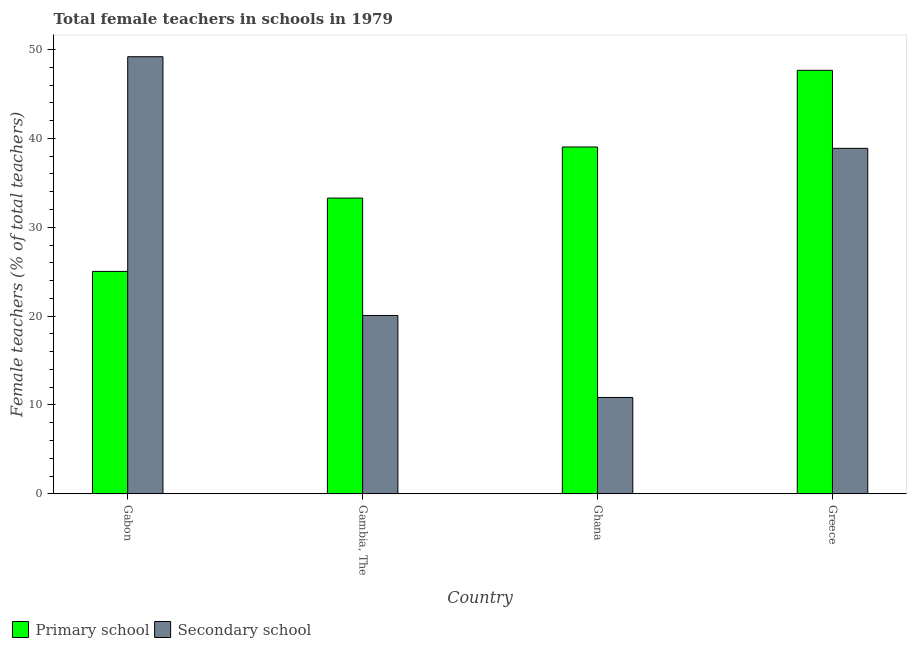How many different coloured bars are there?
Provide a succinct answer. 2. Are the number of bars per tick equal to the number of legend labels?
Offer a very short reply. Yes. Are the number of bars on each tick of the X-axis equal?
Your answer should be compact. Yes. How many bars are there on the 1st tick from the left?
Your answer should be compact. 2. What is the label of the 2nd group of bars from the left?
Your answer should be very brief. Gambia, The. What is the percentage of female teachers in primary schools in Gambia, The?
Keep it short and to the point. 33.28. Across all countries, what is the maximum percentage of female teachers in secondary schools?
Ensure brevity in your answer.  49.19. Across all countries, what is the minimum percentage of female teachers in primary schools?
Your answer should be compact. 25.03. In which country was the percentage of female teachers in secondary schools maximum?
Offer a terse response. Gabon. What is the total percentage of female teachers in secondary schools in the graph?
Your answer should be compact. 118.99. What is the difference between the percentage of female teachers in primary schools in Gabon and that in Ghana?
Your response must be concise. -14. What is the difference between the percentage of female teachers in primary schools in Gabon and the percentage of female teachers in secondary schools in Greece?
Your answer should be compact. -13.85. What is the average percentage of female teachers in secondary schools per country?
Give a very brief answer. 29.75. What is the difference between the percentage of female teachers in secondary schools and percentage of female teachers in primary schools in Ghana?
Ensure brevity in your answer.  -28.19. In how many countries, is the percentage of female teachers in primary schools greater than 36 %?
Offer a terse response. 2. What is the ratio of the percentage of female teachers in secondary schools in Gabon to that in Gambia, The?
Your answer should be very brief. 2.45. Is the percentage of female teachers in primary schools in Gabon less than that in Gambia, The?
Make the answer very short. Yes. Is the difference between the percentage of female teachers in secondary schools in Gabon and Ghana greater than the difference between the percentage of female teachers in primary schools in Gabon and Ghana?
Give a very brief answer. Yes. What is the difference between the highest and the second highest percentage of female teachers in secondary schools?
Your answer should be very brief. 10.31. What is the difference between the highest and the lowest percentage of female teachers in secondary schools?
Provide a succinct answer. 38.34. What does the 1st bar from the left in Greece represents?
Provide a succinct answer. Primary school. What does the 1st bar from the right in Greece represents?
Provide a succinct answer. Secondary school. How many bars are there?
Offer a very short reply. 8. Are all the bars in the graph horizontal?
Offer a very short reply. No. How many countries are there in the graph?
Your answer should be compact. 4. What is the difference between two consecutive major ticks on the Y-axis?
Your answer should be compact. 10. Are the values on the major ticks of Y-axis written in scientific E-notation?
Offer a terse response. No. Does the graph contain grids?
Ensure brevity in your answer.  No. How many legend labels are there?
Keep it short and to the point. 2. What is the title of the graph?
Your answer should be compact. Total female teachers in schools in 1979. What is the label or title of the X-axis?
Keep it short and to the point. Country. What is the label or title of the Y-axis?
Ensure brevity in your answer.  Female teachers (% of total teachers). What is the Female teachers (% of total teachers) in Primary school in Gabon?
Provide a short and direct response. 25.03. What is the Female teachers (% of total teachers) in Secondary school in Gabon?
Ensure brevity in your answer.  49.19. What is the Female teachers (% of total teachers) in Primary school in Gambia, The?
Your response must be concise. 33.28. What is the Female teachers (% of total teachers) of Secondary school in Gambia, The?
Offer a terse response. 20.07. What is the Female teachers (% of total teachers) in Primary school in Ghana?
Offer a very short reply. 39.03. What is the Female teachers (% of total teachers) of Secondary school in Ghana?
Your answer should be compact. 10.85. What is the Female teachers (% of total teachers) in Primary school in Greece?
Your answer should be very brief. 47.66. What is the Female teachers (% of total teachers) of Secondary school in Greece?
Give a very brief answer. 38.88. Across all countries, what is the maximum Female teachers (% of total teachers) in Primary school?
Your response must be concise. 47.66. Across all countries, what is the maximum Female teachers (% of total teachers) in Secondary school?
Your answer should be very brief. 49.19. Across all countries, what is the minimum Female teachers (% of total teachers) in Primary school?
Offer a very short reply. 25.03. Across all countries, what is the minimum Female teachers (% of total teachers) of Secondary school?
Offer a terse response. 10.85. What is the total Female teachers (% of total teachers) of Primary school in the graph?
Provide a succinct answer. 145. What is the total Female teachers (% of total teachers) of Secondary school in the graph?
Provide a short and direct response. 118.99. What is the difference between the Female teachers (% of total teachers) of Primary school in Gabon and that in Gambia, The?
Offer a terse response. -8.25. What is the difference between the Female teachers (% of total teachers) of Secondary school in Gabon and that in Gambia, The?
Offer a very short reply. 29.11. What is the difference between the Female teachers (% of total teachers) of Primary school in Gabon and that in Ghana?
Offer a very short reply. -14. What is the difference between the Female teachers (% of total teachers) in Secondary school in Gabon and that in Ghana?
Keep it short and to the point. 38.34. What is the difference between the Female teachers (% of total teachers) of Primary school in Gabon and that in Greece?
Your answer should be very brief. -22.62. What is the difference between the Female teachers (% of total teachers) in Secondary school in Gabon and that in Greece?
Ensure brevity in your answer.  10.31. What is the difference between the Female teachers (% of total teachers) of Primary school in Gambia, The and that in Ghana?
Your response must be concise. -5.75. What is the difference between the Female teachers (% of total teachers) of Secondary school in Gambia, The and that in Ghana?
Offer a terse response. 9.23. What is the difference between the Female teachers (% of total teachers) of Primary school in Gambia, The and that in Greece?
Provide a short and direct response. -14.38. What is the difference between the Female teachers (% of total teachers) in Secondary school in Gambia, The and that in Greece?
Keep it short and to the point. -18.81. What is the difference between the Female teachers (% of total teachers) in Primary school in Ghana and that in Greece?
Offer a very short reply. -8.62. What is the difference between the Female teachers (% of total teachers) of Secondary school in Ghana and that in Greece?
Ensure brevity in your answer.  -28.03. What is the difference between the Female teachers (% of total teachers) of Primary school in Gabon and the Female teachers (% of total teachers) of Secondary school in Gambia, The?
Offer a very short reply. 4.96. What is the difference between the Female teachers (% of total teachers) in Primary school in Gabon and the Female teachers (% of total teachers) in Secondary school in Ghana?
Make the answer very short. 14.19. What is the difference between the Female teachers (% of total teachers) in Primary school in Gabon and the Female teachers (% of total teachers) in Secondary school in Greece?
Make the answer very short. -13.85. What is the difference between the Female teachers (% of total teachers) of Primary school in Gambia, The and the Female teachers (% of total teachers) of Secondary school in Ghana?
Make the answer very short. 22.43. What is the difference between the Female teachers (% of total teachers) in Primary school in Gambia, The and the Female teachers (% of total teachers) in Secondary school in Greece?
Your answer should be compact. -5.6. What is the difference between the Female teachers (% of total teachers) in Primary school in Ghana and the Female teachers (% of total teachers) in Secondary school in Greece?
Ensure brevity in your answer.  0.15. What is the average Female teachers (% of total teachers) of Primary school per country?
Give a very brief answer. 36.25. What is the average Female teachers (% of total teachers) in Secondary school per country?
Your response must be concise. 29.75. What is the difference between the Female teachers (% of total teachers) of Primary school and Female teachers (% of total teachers) of Secondary school in Gabon?
Ensure brevity in your answer.  -24.16. What is the difference between the Female teachers (% of total teachers) in Primary school and Female teachers (% of total teachers) in Secondary school in Gambia, The?
Ensure brevity in your answer.  13.21. What is the difference between the Female teachers (% of total teachers) in Primary school and Female teachers (% of total teachers) in Secondary school in Ghana?
Provide a succinct answer. 28.19. What is the difference between the Female teachers (% of total teachers) in Primary school and Female teachers (% of total teachers) in Secondary school in Greece?
Offer a terse response. 8.78. What is the ratio of the Female teachers (% of total teachers) of Primary school in Gabon to that in Gambia, The?
Provide a succinct answer. 0.75. What is the ratio of the Female teachers (% of total teachers) in Secondary school in Gabon to that in Gambia, The?
Give a very brief answer. 2.45. What is the ratio of the Female teachers (% of total teachers) of Primary school in Gabon to that in Ghana?
Offer a very short reply. 0.64. What is the ratio of the Female teachers (% of total teachers) in Secondary school in Gabon to that in Ghana?
Offer a terse response. 4.54. What is the ratio of the Female teachers (% of total teachers) of Primary school in Gabon to that in Greece?
Make the answer very short. 0.53. What is the ratio of the Female teachers (% of total teachers) in Secondary school in Gabon to that in Greece?
Provide a succinct answer. 1.27. What is the ratio of the Female teachers (% of total teachers) in Primary school in Gambia, The to that in Ghana?
Offer a terse response. 0.85. What is the ratio of the Female teachers (% of total teachers) in Secondary school in Gambia, The to that in Ghana?
Keep it short and to the point. 1.85. What is the ratio of the Female teachers (% of total teachers) in Primary school in Gambia, The to that in Greece?
Give a very brief answer. 0.7. What is the ratio of the Female teachers (% of total teachers) of Secondary school in Gambia, The to that in Greece?
Give a very brief answer. 0.52. What is the ratio of the Female teachers (% of total teachers) in Primary school in Ghana to that in Greece?
Ensure brevity in your answer.  0.82. What is the ratio of the Female teachers (% of total teachers) of Secondary school in Ghana to that in Greece?
Offer a terse response. 0.28. What is the difference between the highest and the second highest Female teachers (% of total teachers) of Primary school?
Make the answer very short. 8.62. What is the difference between the highest and the second highest Female teachers (% of total teachers) in Secondary school?
Provide a succinct answer. 10.31. What is the difference between the highest and the lowest Female teachers (% of total teachers) in Primary school?
Offer a terse response. 22.62. What is the difference between the highest and the lowest Female teachers (% of total teachers) in Secondary school?
Keep it short and to the point. 38.34. 